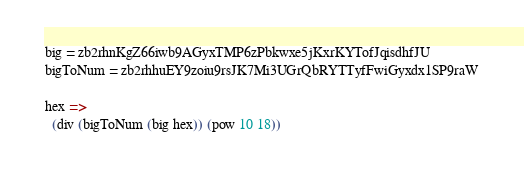Convert code to text. <code><loc_0><loc_0><loc_500><loc_500><_MoonScript_>big = zb2rhnKgZ66iwb9AGyxTMP6zPbkwxe5jKxrKYTofJqisdhfJU
bigToNum = zb2rhhuEY9zoiu9rsJK7Mi3UGrQbRYTTyfFwiGyxdx1SP9raW

hex =>
  (div (bigToNum (big hex)) (pow 10 18))
</code> 